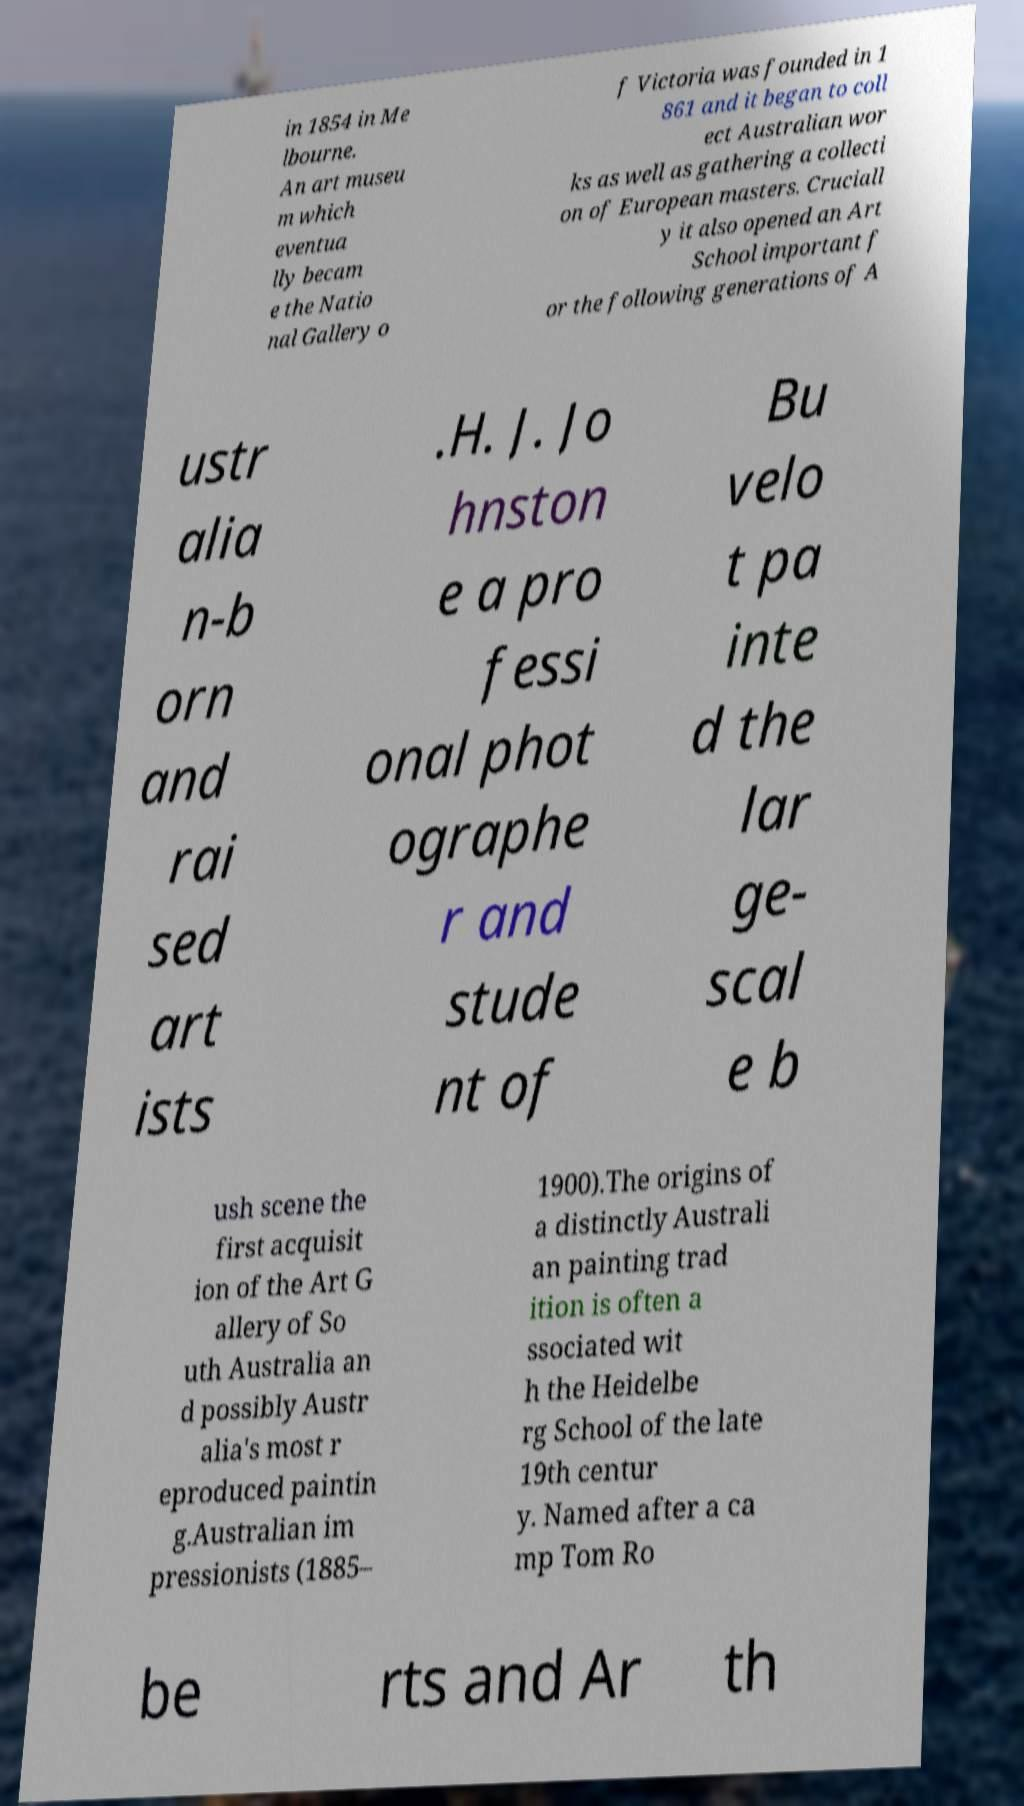Could you extract and type out the text from this image? in 1854 in Me lbourne. An art museu m which eventua lly becam e the Natio nal Gallery o f Victoria was founded in 1 861 and it began to coll ect Australian wor ks as well as gathering a collecti on of European masters. Cruciall y it also opened an Art School important f or the following generations of A ustr alia n-b orn and rai sed art ists .H. J. Jo hnston e a pro fessi onal phot ographe r and stude nt of Bu velo t pa inte d the lar ge- scal e b ush scene the first acquisit ion of the Art G allery of So uth Australia an d possibly Austr alia's most r eproduced paintin g.Australian im pressionists (1885– 1900).The origins of a distinctly Australi an painting trad ition is often a ssociated wit h the Heidelbe rg School of the late 19th centur y. Named after a ca mp Tom Ro be rts and Ar th 